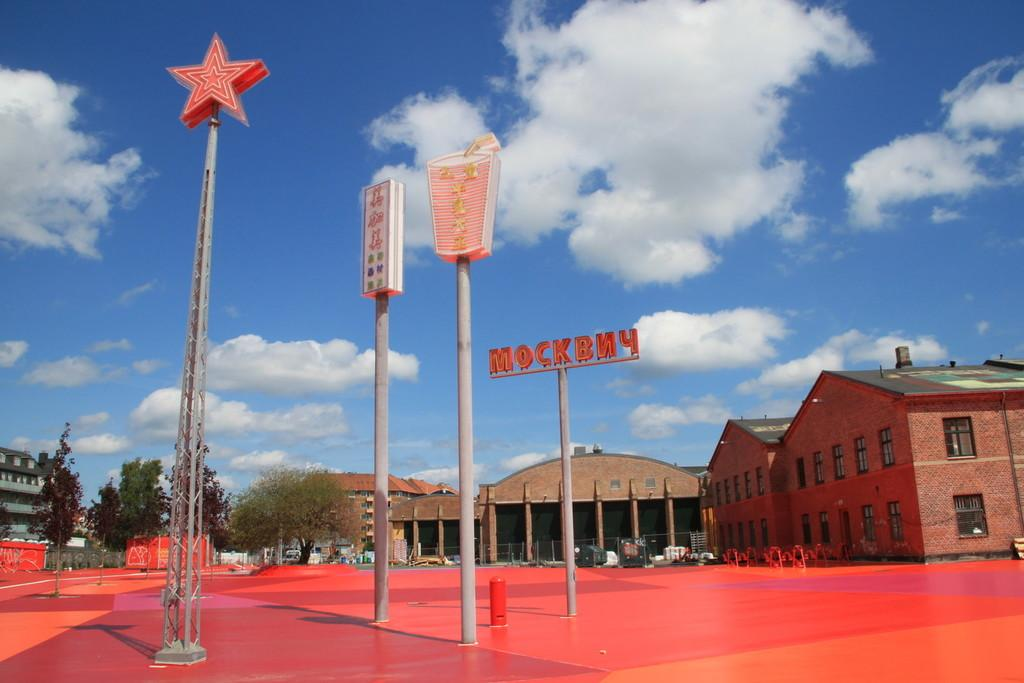What type of structures can be seen in the image? There are poles and boards, as well as buildings, in the image. What type of natural elements are present in the image? There are trees in the image. What can be seen in the background of the image? The sky is visible in the background of the image. Can you describe any other objects in the image? There are unspecified objects in the image. Can you tell me how many monkeys are sitting on the linen in the image? There are no monkeys or linen present in the image. What type of group is gathered around the unspecified objects in the image? There is no group mentioned or visible in the image; only the poles, boards, buildings, trees, and unspecified objects are present. 